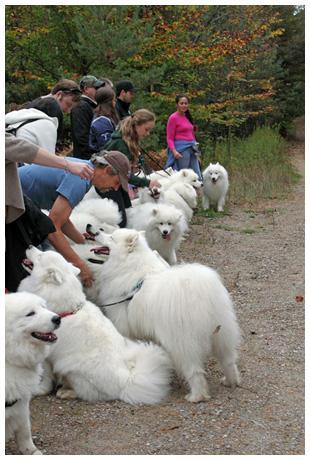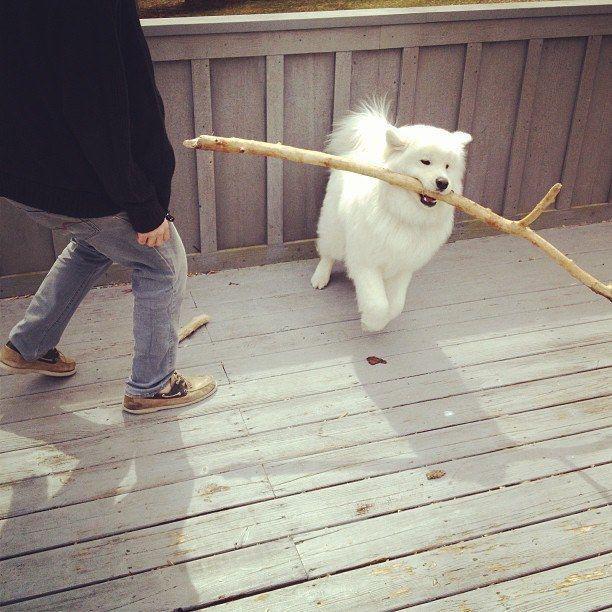The first image is the image on the left, the second image is the image on the right. For the images displayed, is the sentence "At least one dog is laying on a couch." factually correct? Answer yes or no. No. The first image is the image on the left, the second image is the image on the right. For the images displayed, is the sentence "Each image contains exactly one white dog, and at least one image shows a dog in a setting with furniture." factually correct? Answer yes or no. No. 